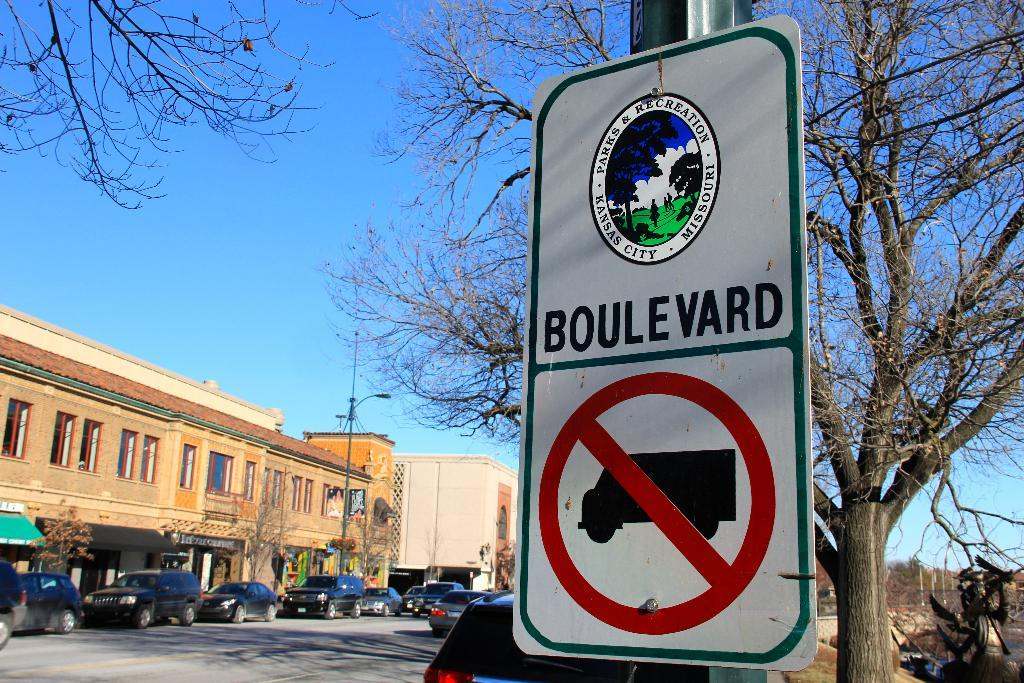<image>
Create a compact narrative representing the image presented. A Kanas City Missouri Parks and Recreation sign showing no commerical trucks allowed. 